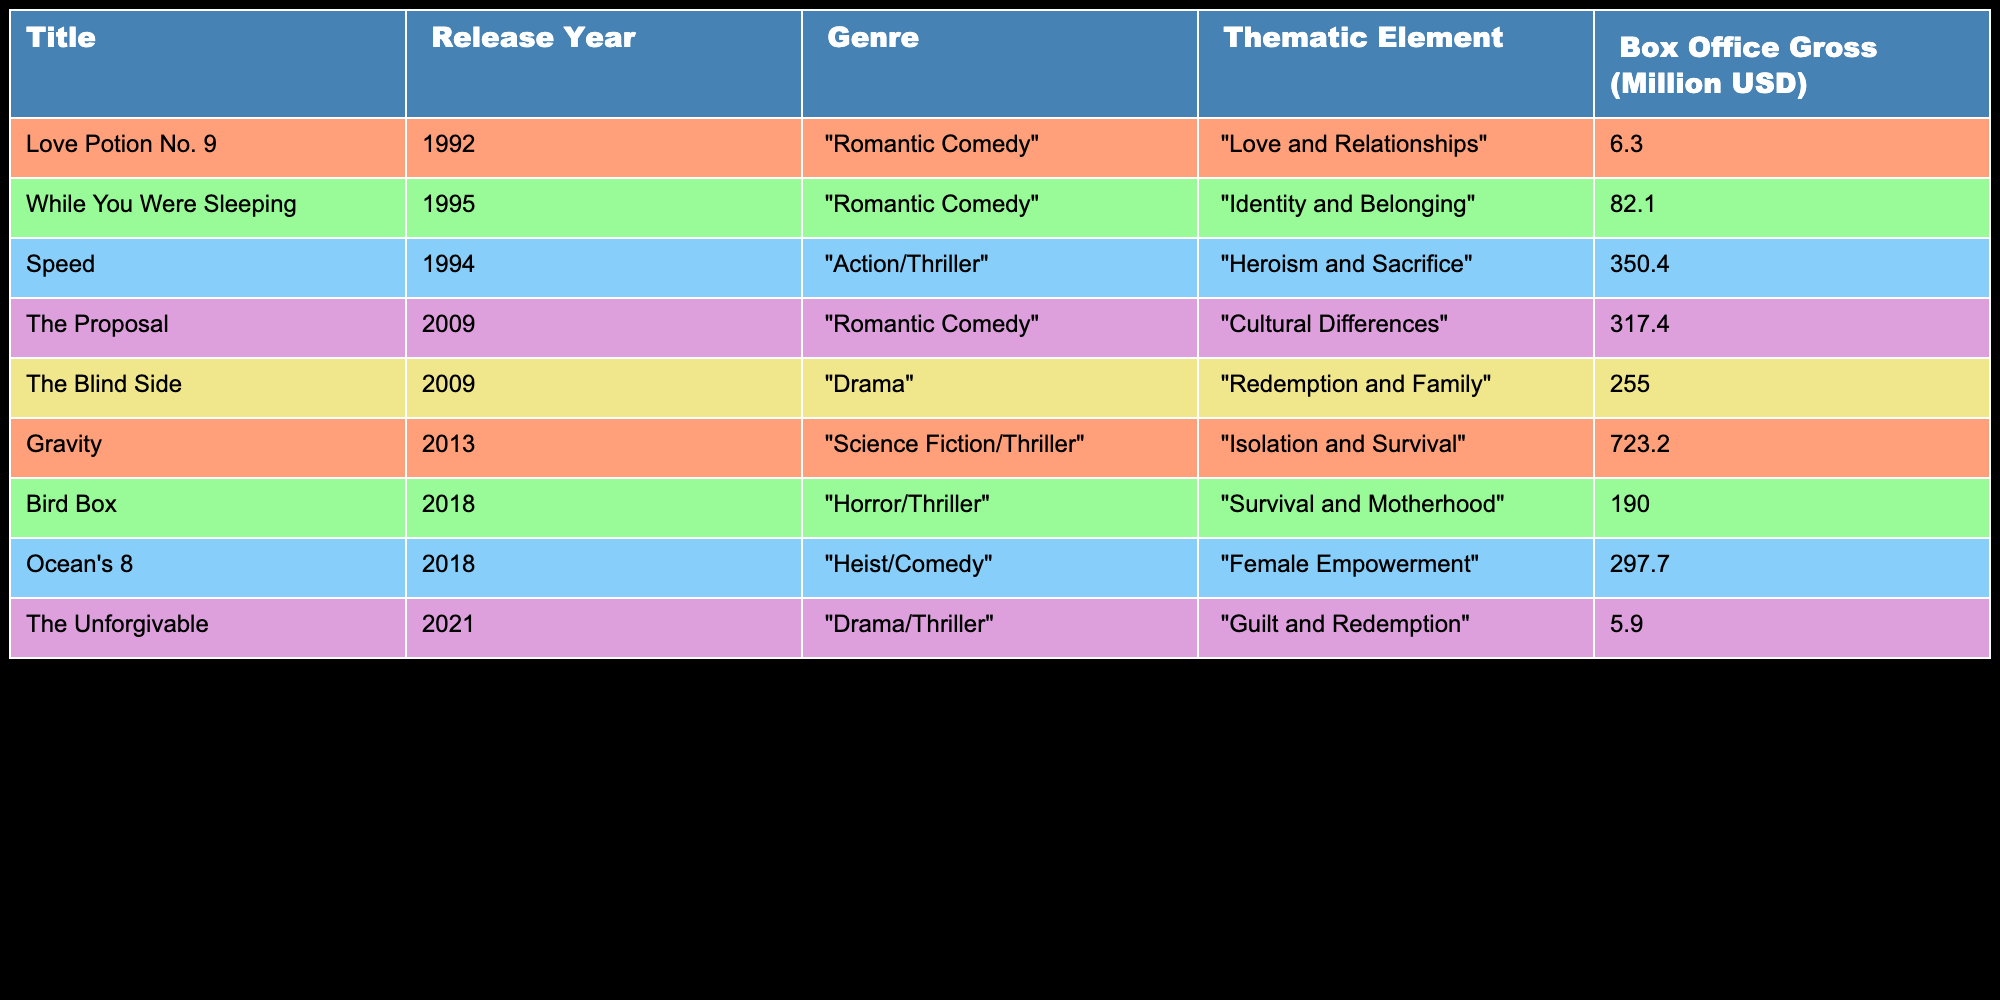What genre does "Bird Box" belong to? The table lists "Bird Box" under the "Genre" column, where it is categorized as "Horror/Thriller".
Answer: Horror/Thriller Which movie released in 2009 had the highest box office gross? The box office gross for "The Proposal" is 317.4 million USD, while "The Blind Side" grossed 255.0 million USD. Since 317.4 million is greater than 255.0 million, "The Proposal" had the highest box office gross in 2009.
Answer: The Proposal What is the total box office gross for Sandra Bullock's movies from 1992 to 2009? Adding the box office grosses of all movies released in this range: Love Potion No. 9 (6.3) + While You Were Sleeping (82.1) + Speed (350.4) + The Proposal (317.4) + The Blind Side (255.0) gives us 6.3 + 82.1 + 350.4 + 317.4 + 255.0 = 1011.2 million USD.
Answer: 1011.2 million USD Did any movies released after 2013 have a box office gross above 200 million USD? The movies listed after 2013 are "Bird Box" and "Ocean's 8", which had gross earnings of 190.0 million and 297.7 million USD respectively. Since 297.7 million is above 200 million, yes, there is a movie that meets this criterion.
Answer: Yes What thematic element is associated with "Gravity"? Looking at the thematic elements in the table, "Gravity" is associated with "Isolation and Survival". This is directly derived from the table's "Thematic Element" column under the row for "Gravity".
Answer: Isolation and Survival Which movie has the lowest box office gross, and what is its amount? The table shows "The Unforgivable" with a box office gross of 5.9 million USD, which is the lowest among all titles listed.
Answer: The Unforgivable, 5.9 million USD What is the average box office gross of Sandra Bullock's movies listed in the table? The total box office gross calculated is 1,990.6 million USD for all seven films. Since there are 7 films, the average is 1,990.6 million / 7 = 284.3 million USD.
Answer: 284.3 million USD How many of Sandra Bullock’s movies from the table focus on redemption as a thematic element? "The Blind Side" and "The Unforgivable" are the movies associated with redemption. Therefore, there are 2 movies in total that focus on this thematic element.
Answer: 2 What is the difference in box office gross between "Speed" and "Gravity"? "Speed" grossed 350.4 million USD and "Gravity" grossed 723.2 million USD. The difference is 723.2 - 350.4 = 372.8 million USD.
Answer: 372.8 million USD 